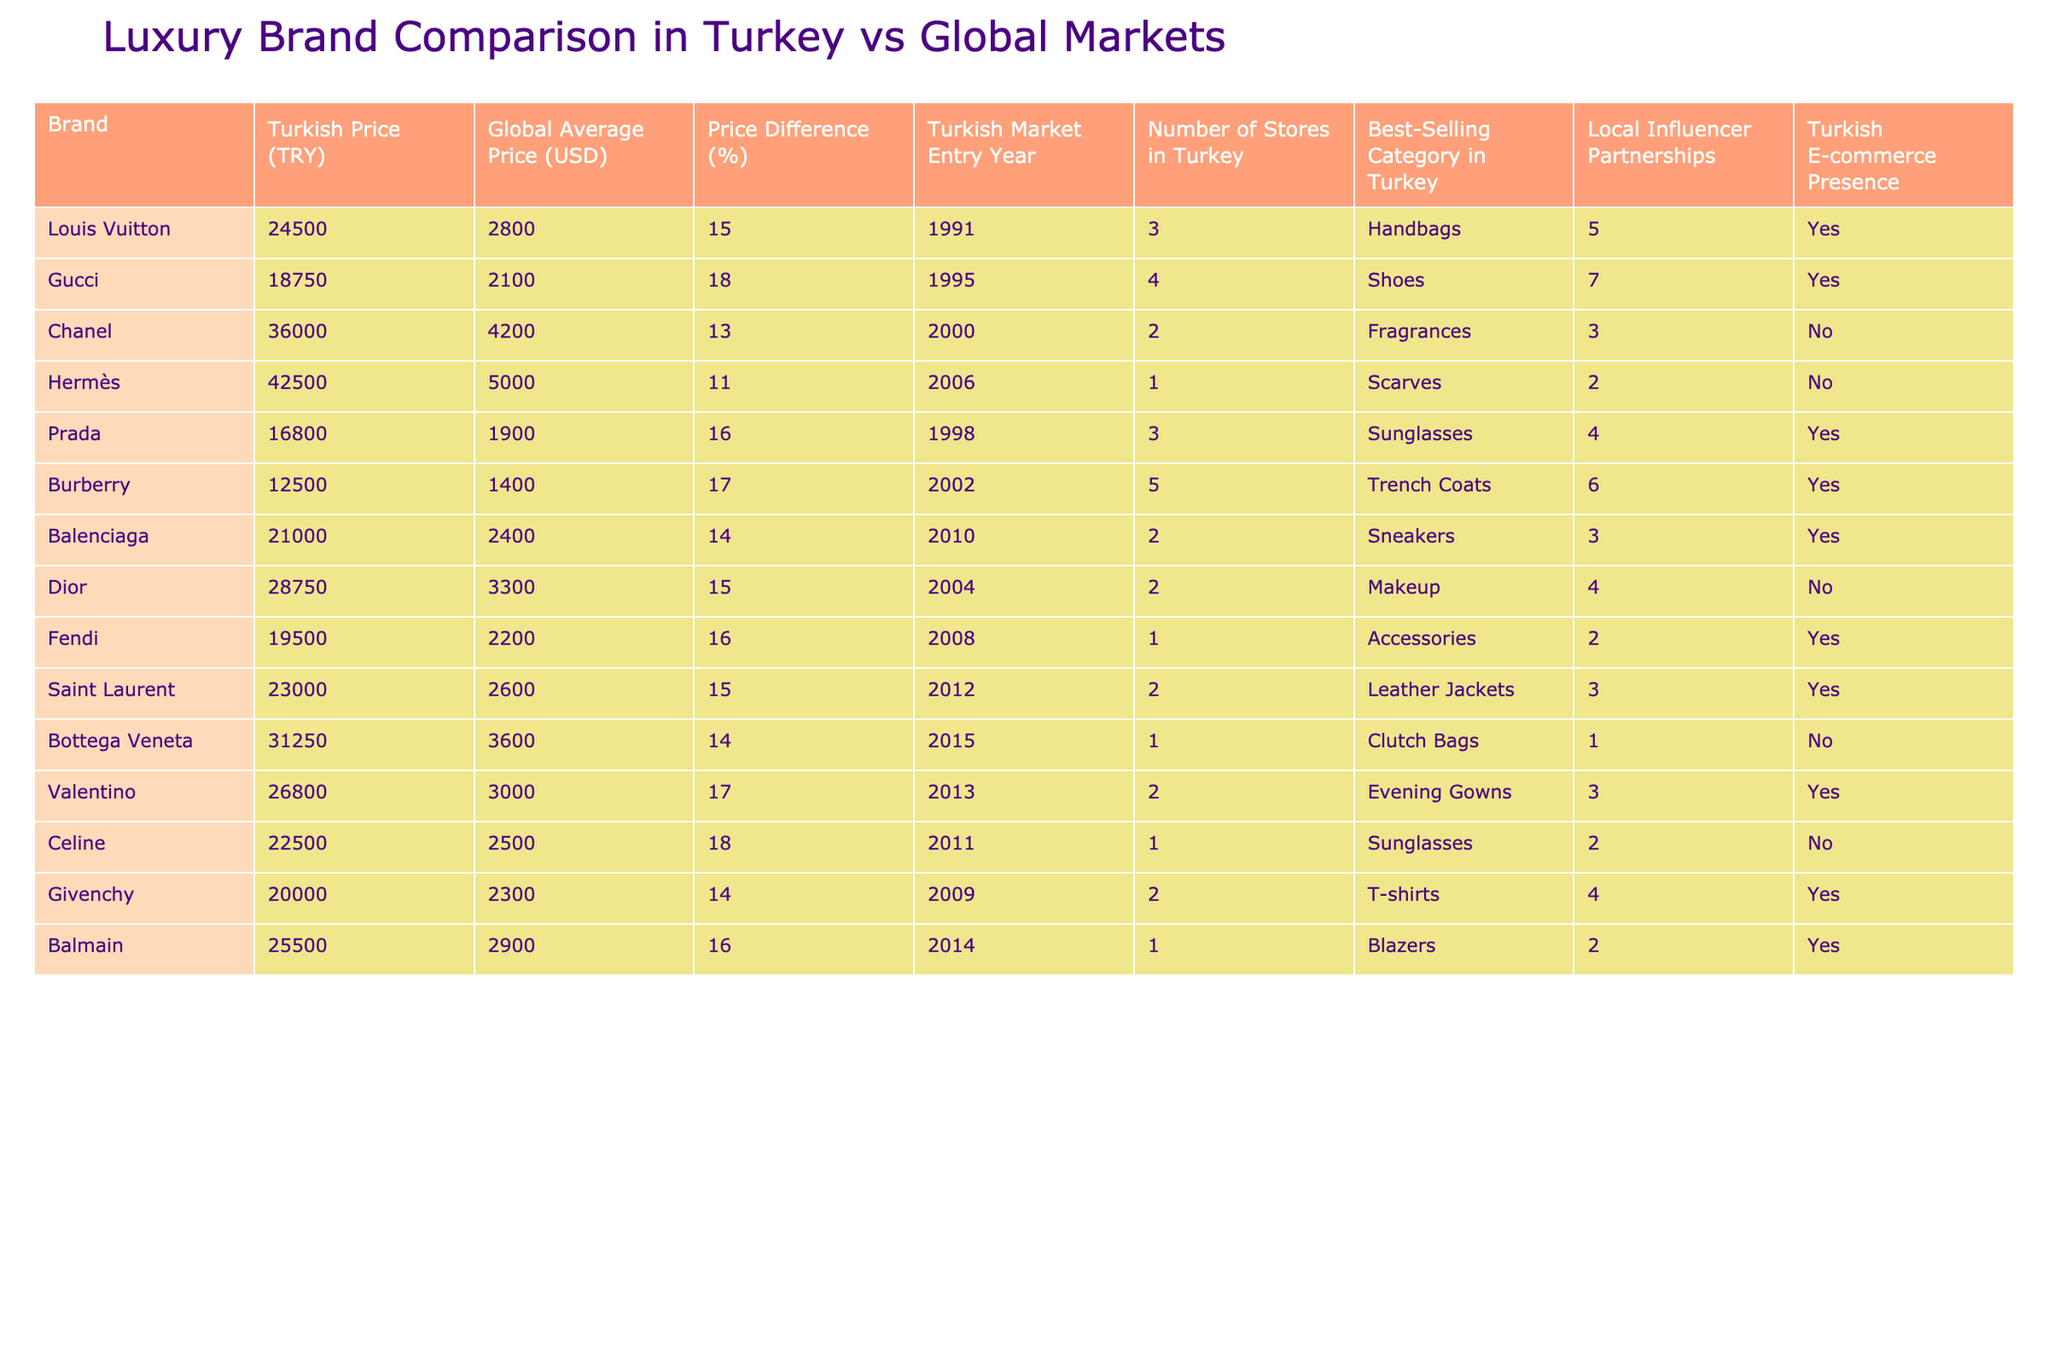What is the price difference percentage of Louis Vuitton in Turkey compared to the global average? The price difference for Louis Vuitton is given in the table as 15%.
Answer: 15% Which brand has the highest Turkish price? By examining the Turkish prices listed, Hermès has the highest price at 42,500 TRY.
Answer: 42,500 TRY What is the best-selling category for Burberry in Turkey? The table lists "Trench Coats" as the best-selling category for Burberry in Turkey.
Answer: Trench Coats Do any brands have a Turkish e-commerce presence? By reviewing the table, we see that the brands with a Turkish e-commerce presence are Louis Vuitton, Gucci, Prada, Burberry, Balenciaga, Fendi, Givenchy, and Balmain.
Answer: Yes Which brand had the latest market entry in Turkey? Hermès entered the Turkish market in 2006, which is the latest year listed for any of the brands.
Answer: Hermès What is the average price difference percentage of the brands listed in the table? The price differences listed are: 15, 18, 13, 11, 16, 17, 14, 15, 16, 18, 14, 16, and 17. Adding these gives  15 + 18 + 13 + 11 + 16 + 17 + 14 + 15 + 16 + 18 + 14 + 16 + 17 =  206. There are 13 brands total, so the average is 206 / 13 ≈ 15.85%.
Answer: Approximately 15.85% Which brand has the fewest number of stores in Turkey? By looking at the "Number of Stores in Turkey" column, we see that Hermès and Bottega Veneta both have 1 store each.
Answer: Hermès and Bottega Veneta What percentage of brands have local influencer partnerships? From the 13 brands, 8 have local influencer partnerships (indicated as "Yes" in the table). To find the percentage, (8 / 13) * 100 ≈ 61.54%.
Answer: Approximately 61.54% Which brand has the best-selling category of "Handbags"? The table identifies Louis Vuitton as the brand with "Handbags" as their best-selling category in Turkey.
Answer: Louis Vuitton Is Dior available in Turkish e-commerce? The table indicates "No" for Dior's Turkish e-commerce presence.
Answer: No Among the brands listed, which one entered the Turkish market first, and in which year? Louis Vuitton is listed as entering the Turkish market in 1991, making it the first brand from the table to do so.
Answer: Louis Vuitton, 1991 